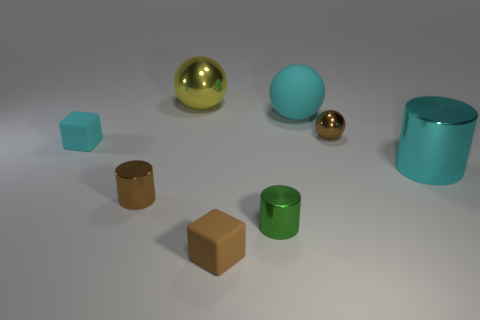Is the color of the large cylinder the same as the matte ball?
Provide a succinct answer. Yes. Does the tiny shiny sphere have the same color as the cube that is in front of the tiny green cylinder?
Provide a succinct answer. Yes. Is the number of small cyan things right of the small brown matte object less than the number of big yellow metal balls that are to the left of the cyan shiny cylinder?
Provide a succinct answer. Yes. There is a small rubber thing that is in front of the brown object to the left of the yellow ball; what is its shape?
Give a very brief answer. Cube. Is there a tiny blue matte thing?
Your response must be concise. No. What color is the large ball that is right of the large yellow ball?
Your response must be concise. Cyan. There is a cylinder that is the same color as the small sphere; what is it made of?
Provide a succinct answer. Metal. Are there any tiny cylinders to the left of the yellow object?
Provide a short and direct response. Yes. Is the number of yellow objects greater than the number of cubes?
Make the answer very short. No. The tiny rubber object behind the large cylinder that is right of the tiny cylinder that is right of the yellow ball is what color?
Provide a succinct answer. Cyan. 